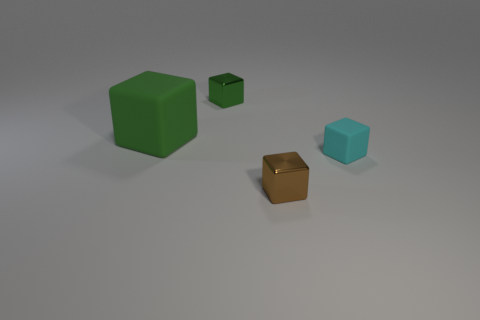Is there any other thing that is the same size as the green rubber object?
Your answer should be very brief. No. What number of other objects are there of the same color as the big object?
Provide a succinct answer. 1. The thing that is both in front of the big matte block and to the left of the cyan object has what shape?
Provide a short and direct response. Cube. Is the number of cyan rubber things greater than the number of big cyan blocks?
Offer a very short reply. Yes. What is the cyan cube made of?
Your response must be concise. Rubber. What is the size of the other metal thing that is the same shape as the brown metal thing?
Make the answer very short. Small. Is there a shiny thing that is right of the tiny thing to the left of the small brown thing?
Your answer should be very brief. Yes. Does the large matte cube have the same color as the small rubber block?
Keep it short and to the point. No. How many other things are the same shape as the large matte object?
Provide a short and direct response. 3. Are there more green metallic things that are in front of the tiny brown block than green metal blocks in front of the large green matte cube?
Provide a short and direct response. No. 